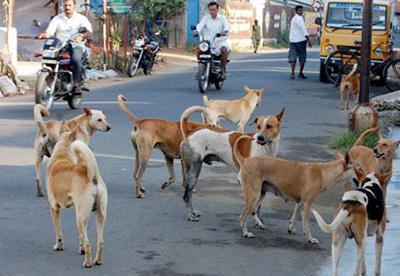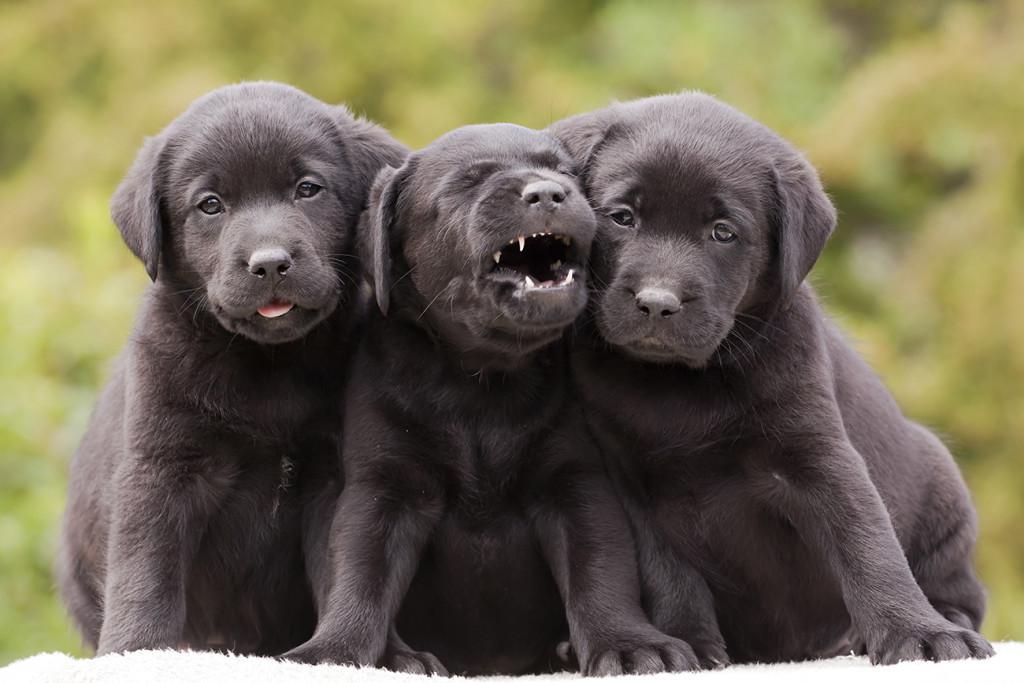The first image is the image on the left, the second image is the image on the right. Assess this claim about the two images: "An image shows one reclining dog, which is wearing a collar.". Correct or not? Answer yes or no. No. The first image is the image on the left, the second image is the image on the right. Examine the images to the left and right. Is the description "The right image contains one or more black labs." accurate? Answer yes or no. Yes. 